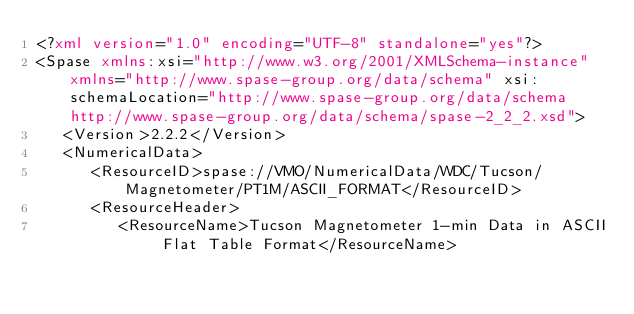<code> <loc_0><loc_0><loc_500><loc_500><_XML_><?xml version="1.0" encoding="UTF-8" standalone="yes"?>
<Spase xmlns:xsi="http://www.w3.org/2001/XMLSchema-instance" xmlns="http://www.spase-group.org/data/schema" xsi:schemaLocation="http://www.spase-group.org/data/schema http://www.spase-group.org/data/schema/spase-2_2_2.xsd">
   <Version>2.2.2</Version>
   <NumericalData>
      <ResourceID>spase://VMO/NumericalData/WDC/Tucson/Magnetometer/PT1M/ASCII_FORMAT</ResourceID>
      <ResourceHeader>
         <ResourceName>Tucson Magnetometer 1-min Data in ASCII Flat Table Format</ResourceName></code> 